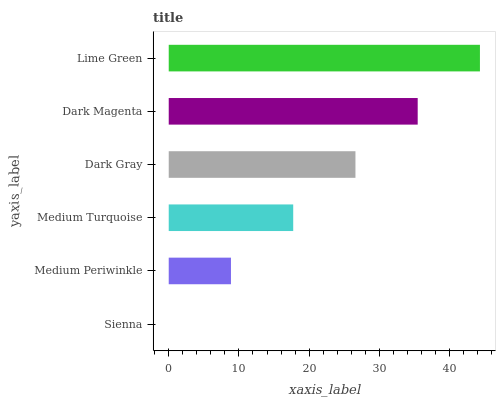Is Sienna the minimum?
Answer yes or no. Yes. Is Lime Green the maximum?
Answer yes or no. Yes. Is Medium Periwinkle the minimum?
Answer yes or no. No. Is Medium Periwinkle the maximum?
Answer yes or no. No. Is Medium Periwinkle greater than Sienna?
Answer yes or no. Yes. Is Sienna less than Medium Periwinkle?
Answer yes or no. Yes. Is Sienna greater than Medium Periwinkle?
Answer yes or no. No. Is Medium Periwinkle less than Sienna?
Answer yes or no. No. Is Dark Gray the high median?
Answer yes or no. Yes. Is Medium Turquoise the low median?
Answer yes or no. Yes. Is Dark Magenta the high median?
Answer yes or no. No. Is Dark Magenta the low median?
Answer yes or no. No. 